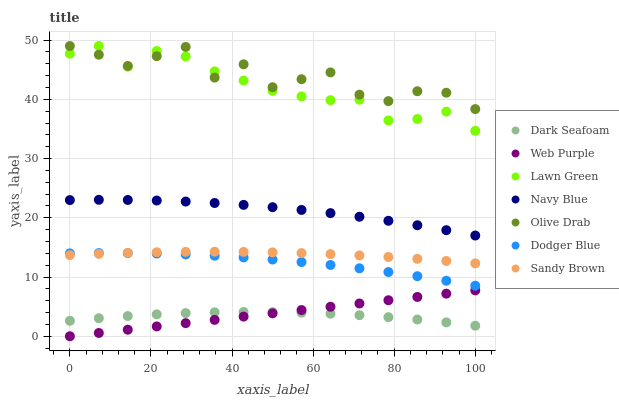Does Dark Seafoam have the minimum area under the curve?
Answer yes or no. Yes. Does Olive Drab have the maximum area under the curve?
Answer yes or no. Yes. Does Navy Blue have the minimum area under the curve?
Answer yes or no. No. Does Navy Blue have the maximum area under the curve?
Answer yes or no. No. Is Web Purple the smoothest?
Answer yes or no. Yes. Is Olive Drab the roughest?
Answer yes or no. Yes. Is Navy Blue the smoothest?
Answer yes or no. No. Is Navy Blue the roughest?
Answer yes or no. No. Does Web Purple have the lowest value?
Answer yes or no. Yes. Does Navy Blue have the lowest value?
Answer yes or no. No. Does Olive Drab have the highest value?
Answer yes or no. Yes. Does Navy Blue have the highest value?
Answer yes or no. No. Is Sandy Brown less than Navy Blue?
Answer yes or no. Yes. Is Lawn Green greater than Web Purple?
Answer yes or no. Yes. Does Olive Drab intersect Lawn Green?
Answer yes or no. Yes. Is Olive Drab less than Lawn Green?
Answer yes or no. No. Is Olive Drab greater than Lawn Green?
Answer yes or no. No. Does Sandy Brown intersect Navy Blue?
Answer yes or no. No. 